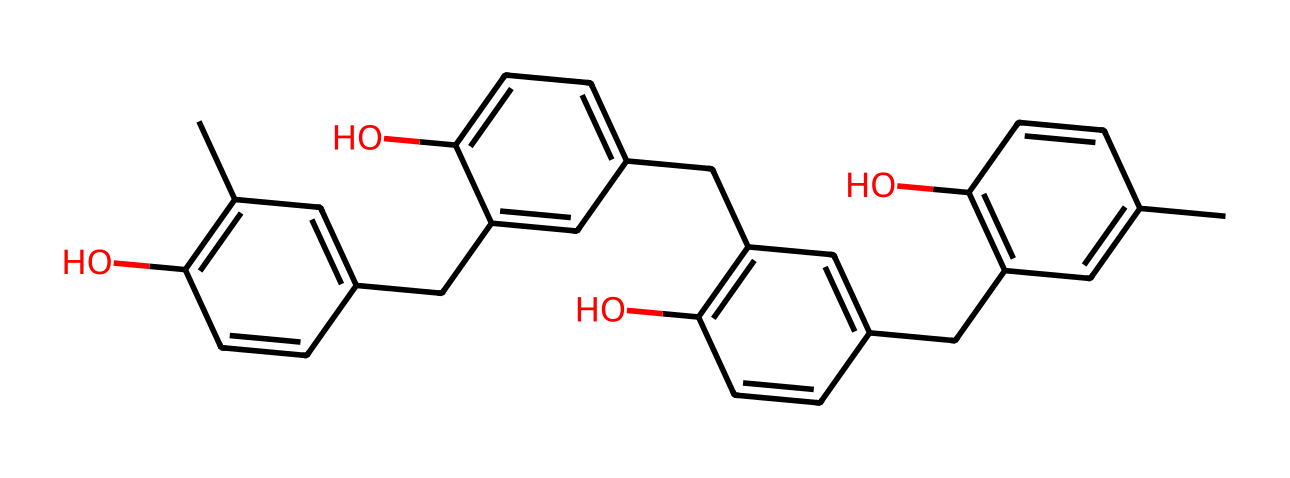What is the molecular formula of DNQ-Novolac? To determine the molecular formula, count the carbon (C), hydrogen (H), and oxygen (O) atoms from the structure. The structure includes 21 carbon atoms, 22 hydrogen atoms, and 4 oxygen atoms. Therefore, the molecular formula is C21H22O4.
Answer: C21H22O4 How many hydroxyl (–OH) groups are present in the chemical structure? By analyzing the structure, we can identify the –OH groups by locating the oxygen atoms attached to hydrogen atoms. There are four –OH groups present in the chemical structure.
Answer: 4 What type of chemical reaction does DNQ-Novolac undergo during the photoresist process? DNQ-Novolac undergoes a photochemical reaction where it becomes soluble in alkaline developers upon exposure to UV light. This transformation is critical for its function as a positive photoresist.
Answer: photochemical reaction What is the role of phenolic structures in DNQ-Novolac? The phenolic structures in DNQ-Novolac contribute to the crosslinking and thermal stability of the photoresist. They enhance the photoresist's performance in circuit board manufacturing by providing mechanical strength and resistance to chemicals.
Answer: stability Which functional group primarily allows DNQ-Novolac to act as a positive photoresist? The presence of the novolak resin, which includes phenolic structures and is modified with DNQ (dihydroxy naphthoquinone), is crucial for its positive photoresist properties. The DNQ component allows it to change solubility upon UV exposure.
Answer: novolak resin 